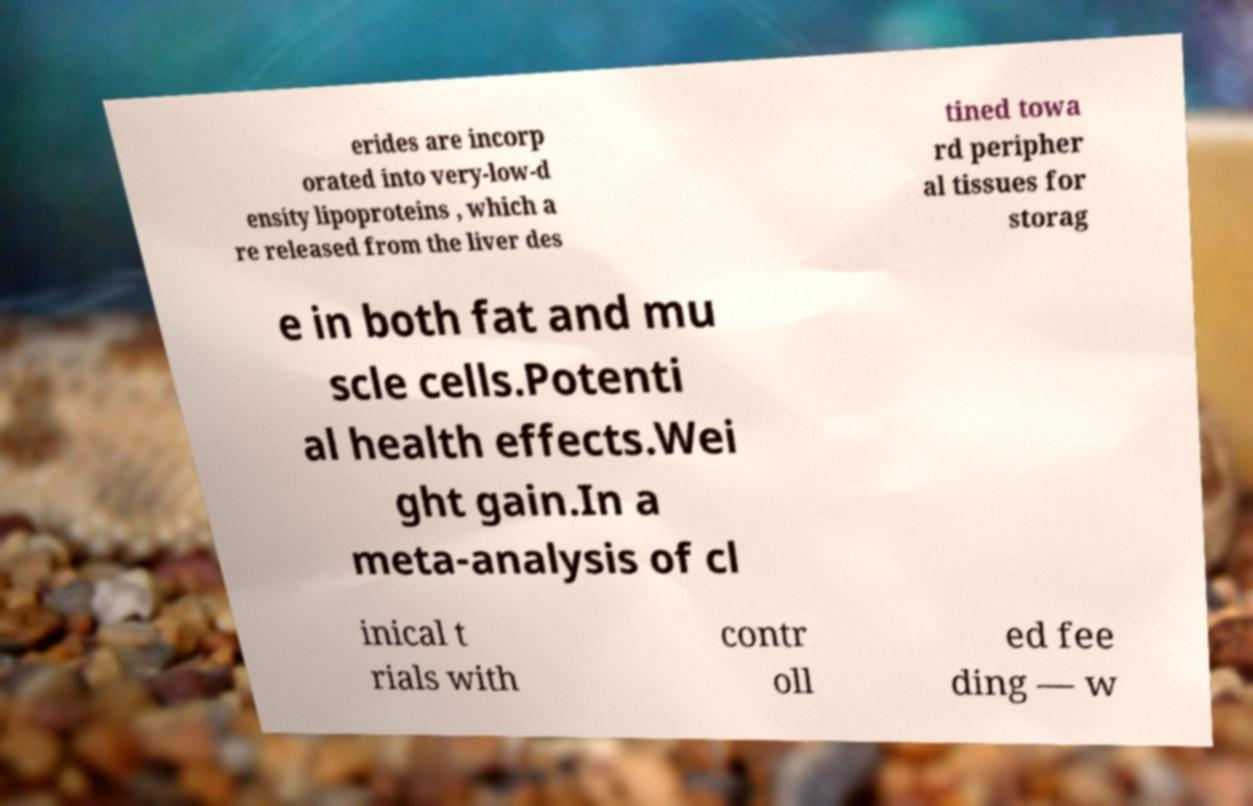Can you accurately transcribe the text from the provided image for me? erides are incorp orated into very-low-d ensity lipoproteins , which a re released from the liver des tined towa rd peripher al tissues for storag e in both fat and mu scle cells.Potenti al health effects.Wei ght gain.In a meta-analysis of cl inical t rials with contr oll ed fee ding — w 